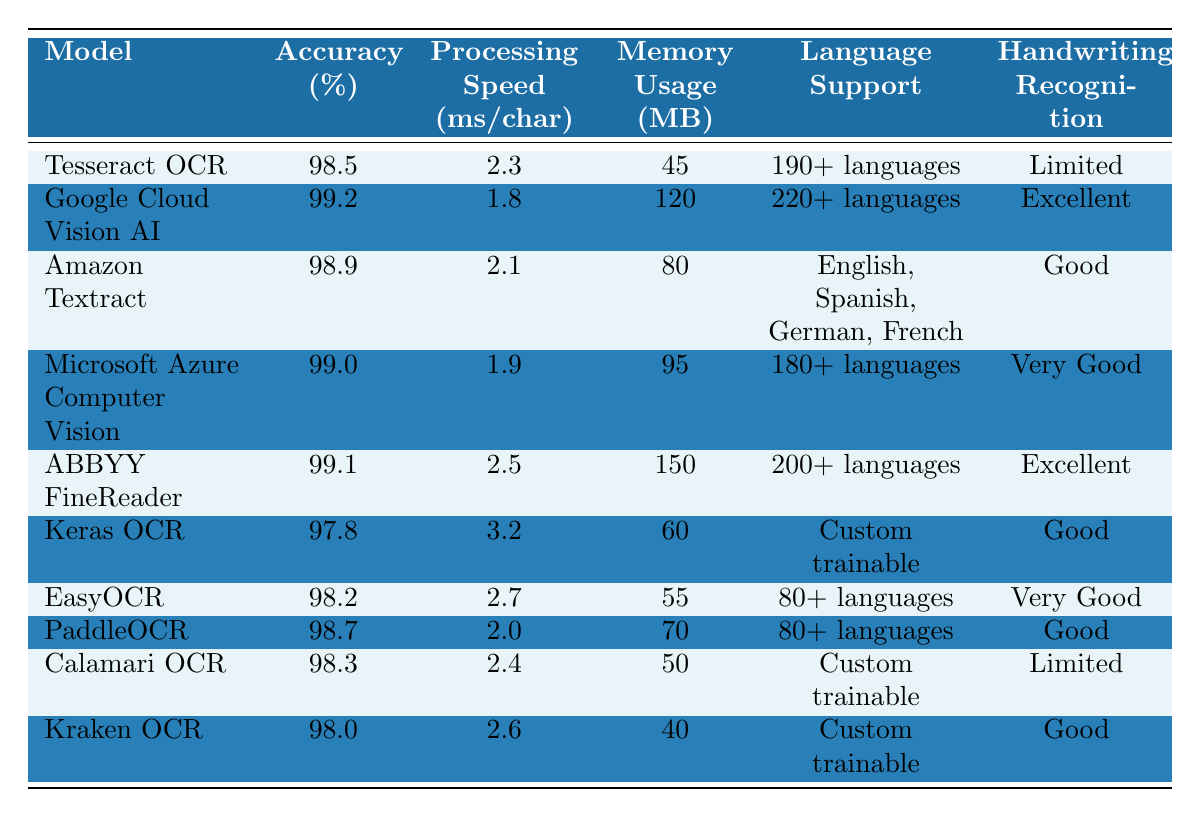What is the accuracy of Google Cloud Vision AI? The table lists Google Cloud Vision AI with an accuracy of 99.2%.
Answer: 99.2% Which model has the highest memory usage? The table shows ABBYY FineReader has the highest memory usage of 150 MB.
Answer: 150 MB Is Tesseract OCR known for handwriting recognition? Tesseract OCR is marked as "Limited" for handwriting recognition in the table.
Answer: No What is the average processing speed of the models listed? The processing speeds are (2.3 + 1.8 + 2.1 + 1.9 + 2.5 + 3.2 + 2.7 + 2.0 + 2.4 + 2.6) ms/char = 24.5 ms/char for 10 models, so the average is 24.5 / 10 = 2.45 ms/char.
Answer: 2.45 ms/char Which model supports the most languages? Google Cloud Vision AI supports 220+ languages, which is the most among the listed models.
Answer: Google Cloud Vision AI How does the processing speed of Google Cloud Vision AI compare with that of PaddleOCR? PaddleOCR's processing speed is 2.0 ms/char, while Google Cloud Vision AI is 1.8 ms/char, so Google Cloud Vision AI is faster by 0.2 ms/char.
Answer: Google Cloud Vision AI is faster by 0.2 ms/char What percentage difference in accuracy exists between Keras OCR and EasyOCR? Keras OCR has an accuracy of 97.8% and EasyOCR has 98.2%, the difference is 98.2 - 97.8 = 0.4%, so the percentage difference is 0.4%.
Answer: 0.4% Which model has the best handwriting recognition capability? Google Cloud Vision AI is rated "Excellent" for handwriting recognition, the highest among all mentioned models.
Answer: Google Cloud Vision AI If you were to choose a model that balances high accuracy and low memory usage, which one would it be based on the table? Microsoft Azure Computer Vision has an accuracy of 99.0% and memory usage of 95 MB, balancing both high accuracy and lower memory usage compared to others.
Answer: Microsoft Azure Computer Vision Is there any model that supports fewer than 80 languages? No model listed supports fewer than 80 languages, as all listed, including Keras OCR and EasyOCR, support at least 80 languages.
Answer: No What is the lowest accuracy among the models presented? Keras OCR has the lowest accuracy at 97.8% according to the table.
Answer: 97.8% 